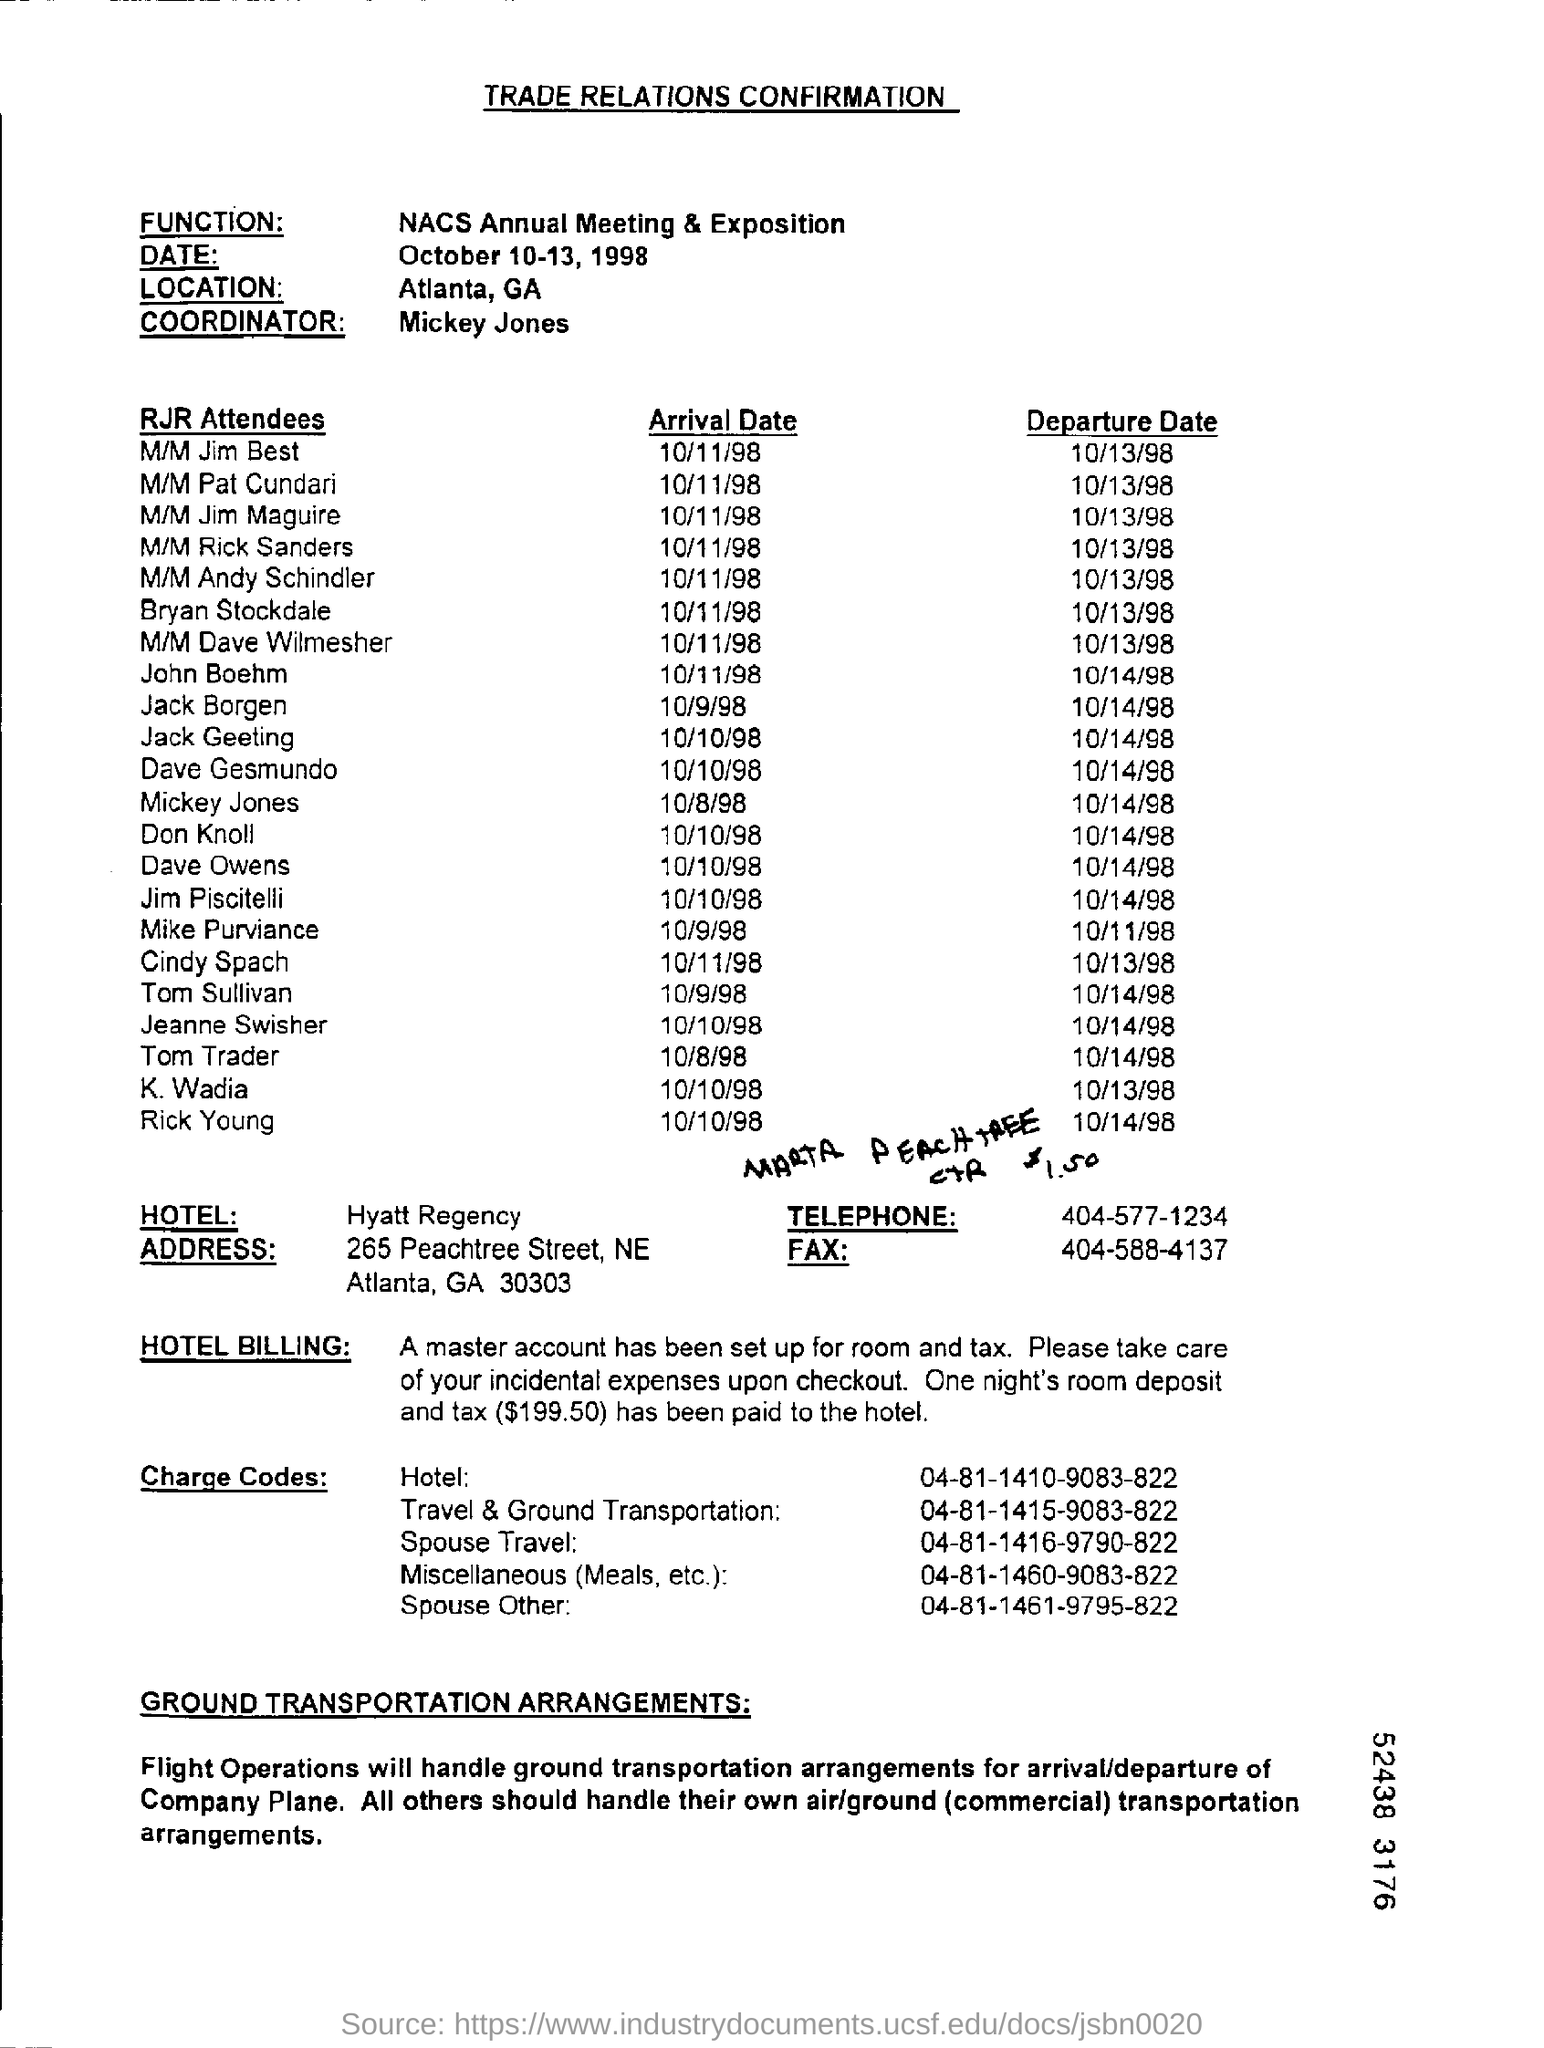What is the function?
Offer a very short reply. NACS Annual Meeting & Exposition. What is the date?
Provide a succinct answer. October 10-13, 1998. What is the location?
Your answer should be compact. Atlanta, GA. What is the name of coordinator?
Give a very brief answer. Mickey Jones. What is the name of hotel?
Your answer should be compact. Hyatt Regency. 